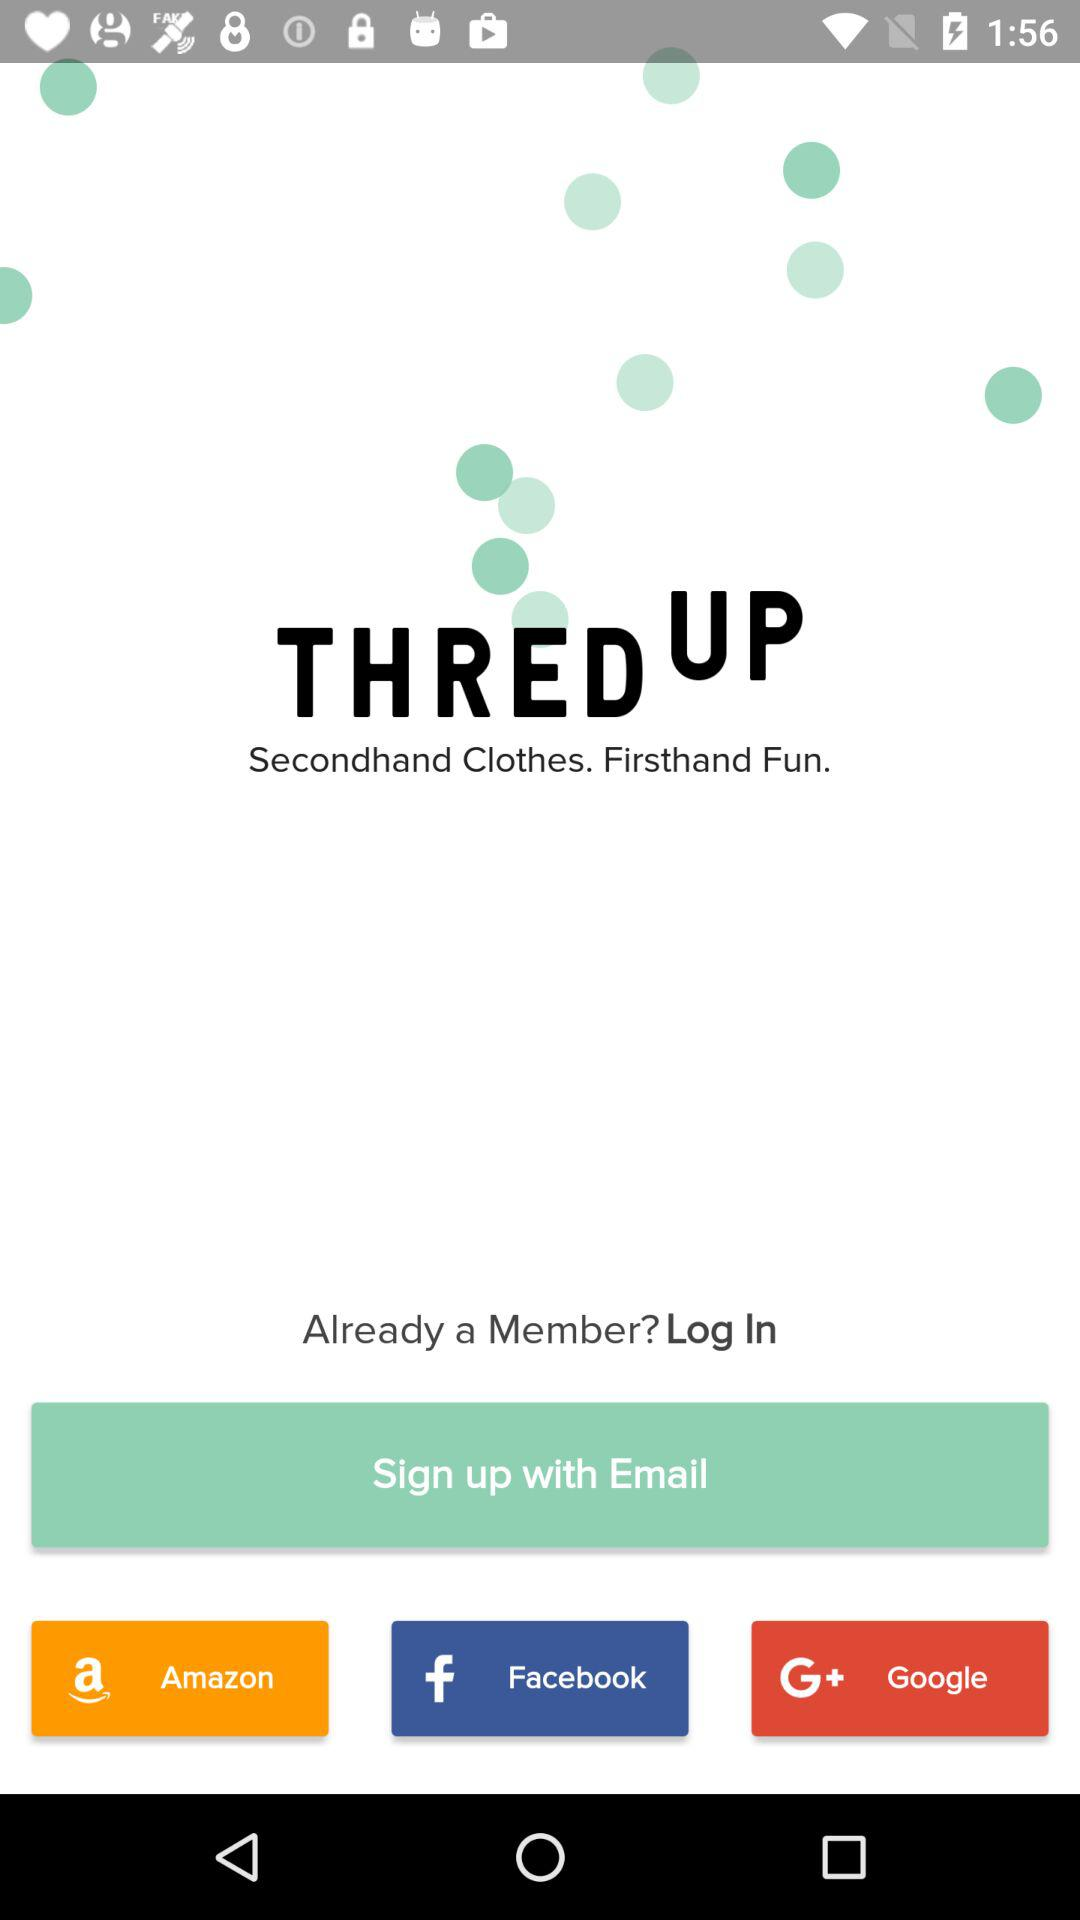Which application can we use to log in? You can use "Amazon", "Facebook" and "Google" to login. 